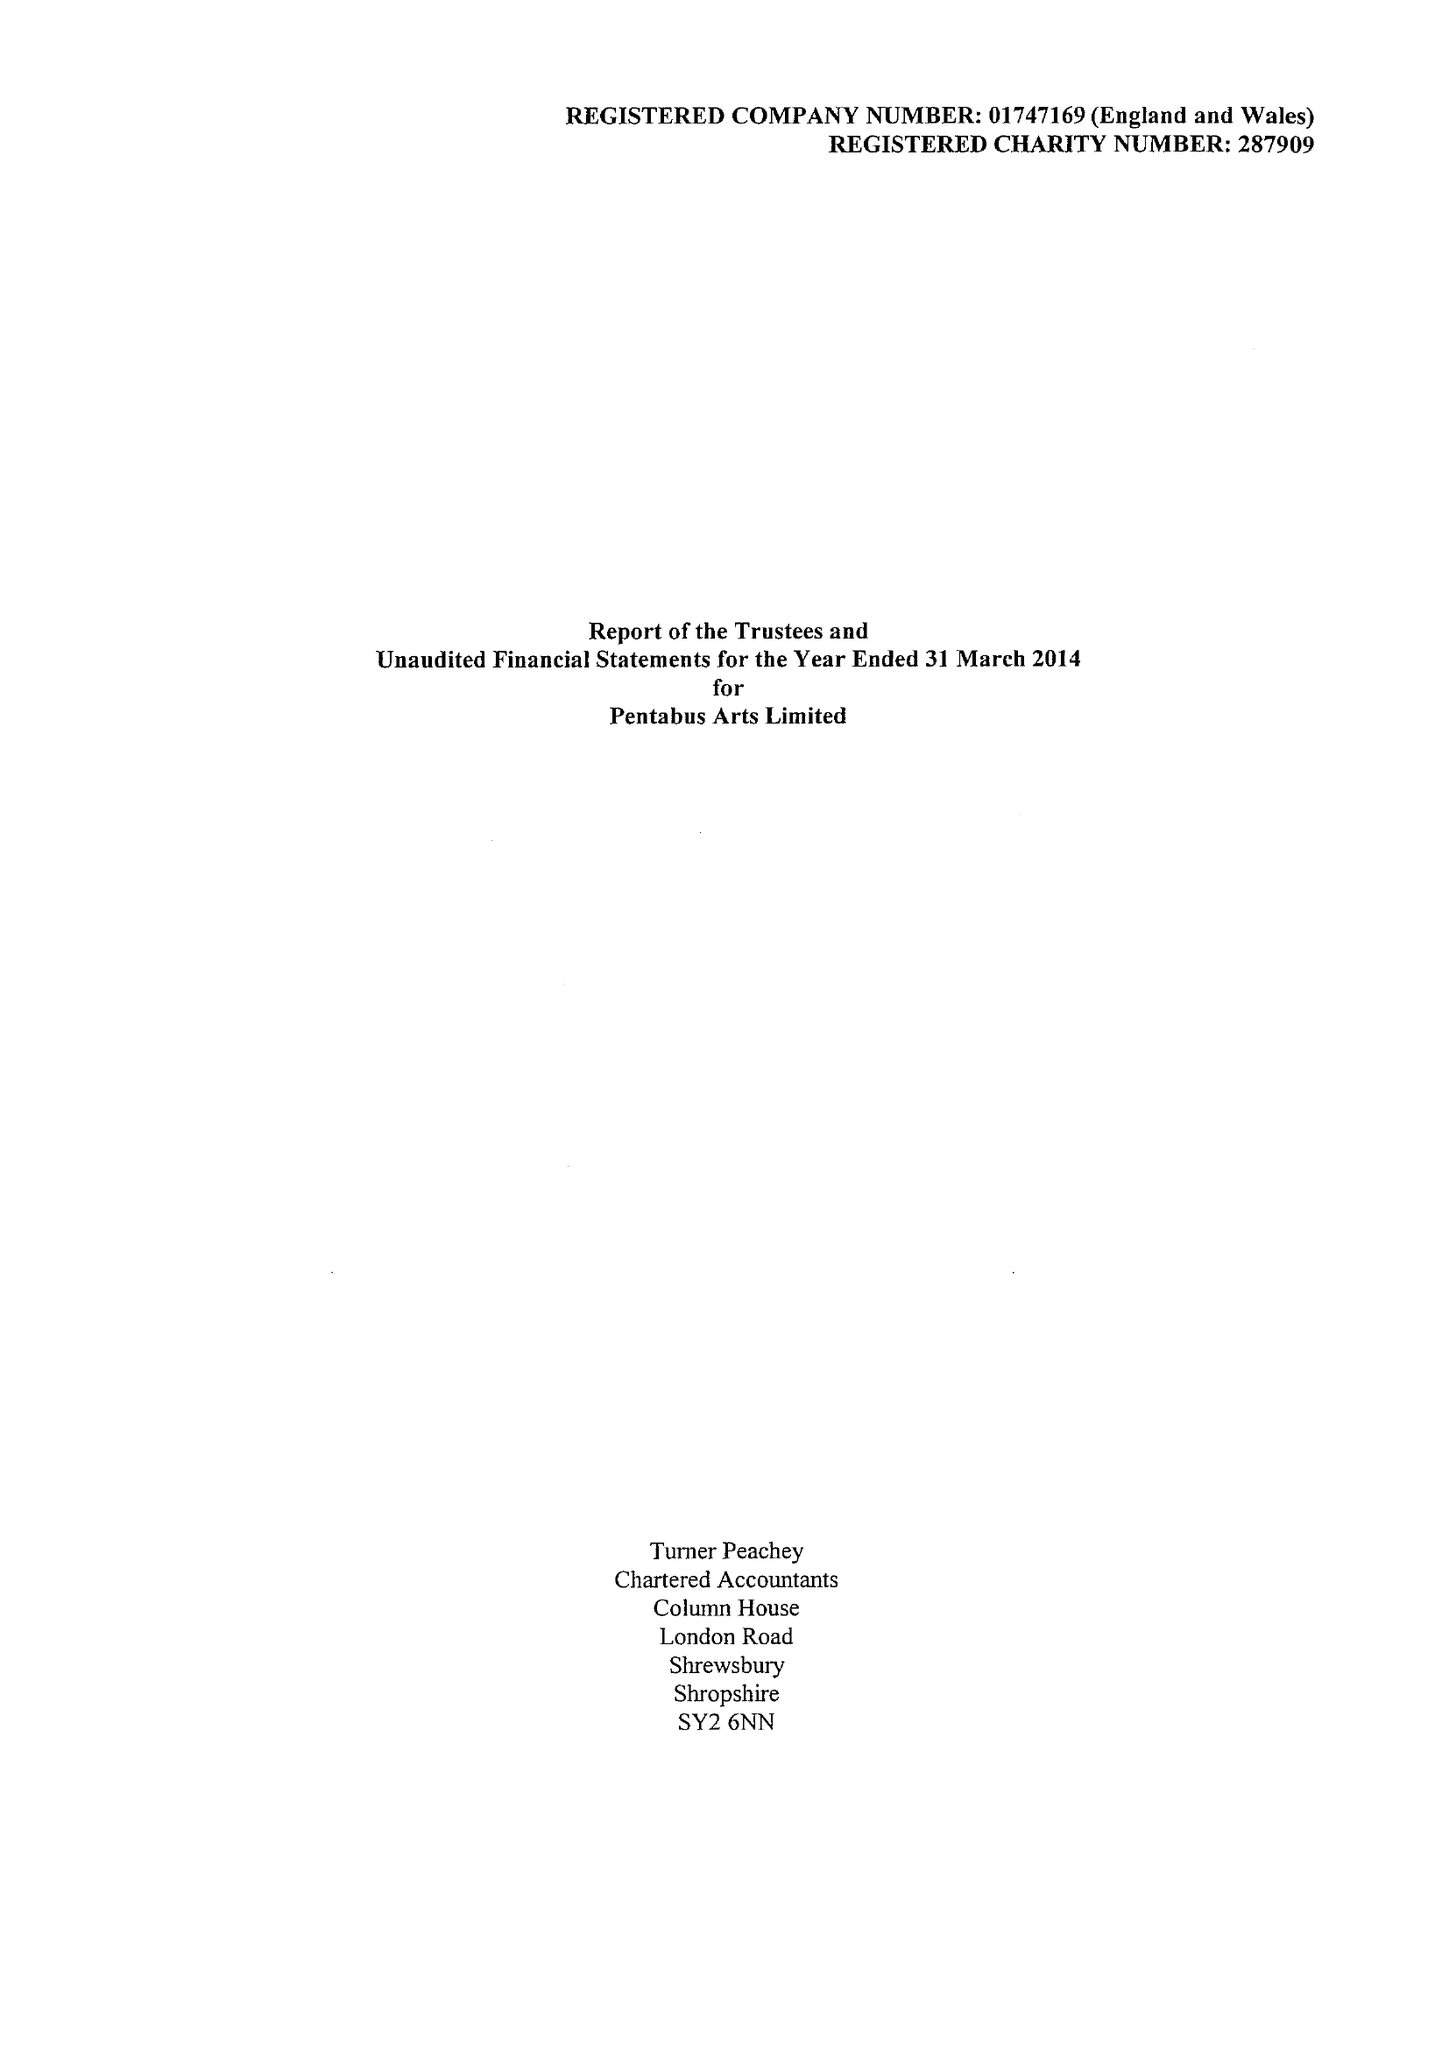What is the value for the income_annually_in_british_pounds?
Answer the question using a single word or phrase. 272599.00 